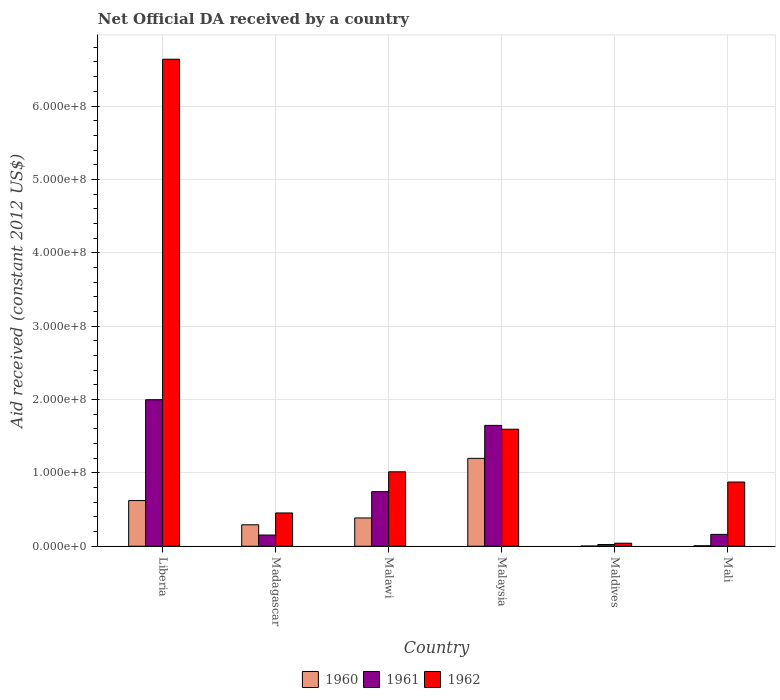Are the number of bars per tick equal to the number of legend labels?
Keep it short and to the point. Yes. How many bars are there on the 6th tick from the left?
Offer a very short reply. 3. What is the label of the 6th group of bars from the left?
Your answer should be very brief. Mali. In how many cases, is the number of bars for a given country not equal to the number of legend labels?
Ensure brevity in your answer.  0. What is the net official development assistance aid received in 1961 in Madagascar?
Your response must be concise. 1.53e+07. Across all countries, what is the maximum net official development assistance aid received in 1962?
Provide a short and direct response. 6.64e+08. Across all countries, what is the minimum net official development assistance aid received in 1961?
Make the answer very short. 2.33e+06. In which country was the net official development assistance aid received in 1961 maximum?
Provide a short and direct response. Liberia. In which country was the net official development assistance aid received in 1960 minimum?
Keep it short and to the point. Maldives. What is the total net official development assistance aid received in 1960 in the graph?
Offer a terse response. 2.51e+08. What is the difference between the net official development assistance aid received in 1960 in Madagascar and that in Maldives?
Make the answer very short. 2.90e+07. What is the difference between the net official development assistance aid received in 1961 in Madagascar and the net official development assistance aid received in 1962 in Malaysia?
Provide a succinct answer. -1.44e+08. What is the average net official development assistance aid received in 1960 per country?
Give a very brief answer. 4.18e+07. What is the difference between the net official development assistance aid received of/in 1961 and net official development assistance aid received of/in 1962 in Malawi?
Make the answer very short. -2.70e+07. What is the ratio of the net official development assistance aid received in 1960 in Liberia to that in Madagascar?
Keep it short and to the point. 2.13. Is the net official development assistance aid received in 1960 in Malawi less than that in Mali?
Keep it short and to the point. No. What is the difference between the highest and the second highest net official development assistance aid received in 1961?
Your answer should be very brief. 1.25e+08. What is the difference between the highest and the lowest net official development assistance aid received in 1960?
Provide a succinct answer. 1.20e+08. Is the sum of the net official development assistance aid received in 1961 in Madagascar and Malaysia greater than the maximum net official development assistance aid received in 1962 across all countries?
Ensure brevity in your answer.  No. What does the 3rd bar from the right in Madagascar represents?
Provide a succinct answer. 1960. How many bars are there?
Ensure brevity in your answer.  18. How many countries are there in the graph?
Offer a very short reply. 6. Does the graph contain grids?
Give a very brief answer. Yes. Where does the legend appear in the graph?
Your answer should be very brief. Bottom center. How are the legend labels stacked?
Offer a very short reply. Horizontal. What is the title of the graph?
Your response must be concise. Net Official DA received by a country. What is the label or title of the X-axis?
Your response must be concise. Country. What is the label or title of the Y-axis?
Your answer should be very brief. Aid received (constant 2012 US$). What is the Aid received (constant 2012 US$) of 1960 in Liberia?
Ensure brevity in your answer.  6.23e+07. What is the Aid received (constant 2012 US$) in 1961 in Liberia?
Your response must be concise. 2.00e+08. What is the Aid received (constant 2012 US$) in 1962 in Liberia?
Your answer should be very brief. 6.64e+08. What is the Aid received (constant 2012 US$) of 1960 in Madagascar?
Your answer should be compact. 2.92e+07. What is the Aid received (constant 2012 US$) in 1961 in Madagascar?
Ensure brevity in your answer.  1.53e+07. What is the Aid received (constant 2012 US$) in 1962 in Madagascar?
Provide a succinct answer. 4.54e+07. What is the Aid received (constant 2012 US$) in 1960 in Malawi?
Give a very brief answer. 3.86e+07. What is the Aid received (constant 2012 US$) in 1961 in Malawi?
Make the answer very short. 7.44e+07. What is the Aid received (constant 2012 US$) in 1962 in Malawi?
Your answer should be compact. 1.01e+08. What is the Aid received (constant 2012 US$) of 1960 in Malaysia?
Offer a terse response. 1.20e+08. What is the Aid received (constant 2012 US$) of 1961 in Malaysia?
Make the answer very short. 1.65e+08. What is the Aid received (constant 2012 US$) in 1962 in Malaysia?
Provide a succinct answer. 1.59e+08. What is the Aid received (constant 2012 US$) of 1961 in Maldives?
Your answer should be very brief. 2.33e+06. What is the Aid received (constant 2012 US$) of 1962 in Maldives?
Keep it short and to the point. 4.15e+06. What is the Aid received (constant 2012 US$) in 1960 in Mali?
Give a very brief answer. 6.60e+05. What is the Aid received (constant 2012 US$) of 1961 in Mali?
Keep it short and to the point. 1.62e+07. What is the Aid received (constant 2012 US$) in 1962 in Mali?
Ensure brevity in your answer.  8.75e+07. Across all countries, what is the maximum Aid received (constant 2012 US$) of 1960?
Give a very brief answer. 1.20e+08. Across all countries, what is the maximum Aid received (constant 2012 US$) of 1961?
Your answer should be compact. 2.00e+08. Across all countries, what is the maximum Aid received (constant 2012 US$) of 1962?
Provide a succinct answer. 6.64e+08. Across all countries, what is the minimum Aid received (constant 2012 US$) of 1960?
Offer a very short reply. 2.70e+05. Across all countries, what is the minimum Aid received (constant 2012 US$) in 1961?
Provide a short and direct response. 2.33e+06. Across all countries, what is the minimum Aid received (constant 2012 US$) in 1962?
Your answer should be very brief. 4.15e+06. What is the total Aid received (constant 2012 US$) of 1960 in the graph?
Provide a short and direct response. 2.51e+08. What is the total Aid received (constant 2012 US$) of 1961 in the graph?
Your answer should be very brief. 4.73e+08. What is the total Aid received (constant 2012 US$) in 1962 in the graph?
Ensure brevity in your answer.  1.06e+09. What is the difference between the Aid received (constant 2012 US$) in 1960 in Liberia and that in Madagascar?
Your response must be concise. 3.30e+07. What is the difference between the Aid received (constant 2012 US$) of 1961 in Liberia and that in Madagascar?
Provide a succinct answer. 1.84e+08. What is the difference between the Aid received (constant 2012 US$) in 1962 in Liberia and that in Madagascar?
Make the answer very short. 6.18e+08. What is the difference between the Aid received (constant 2012 US$) of 1960 in Liberia and that in Malawi?
Provide a succinct answer. 2.37e+07. What is the difference between the Aid received (constant 2012 US$) in 1961 in Liberia and that in Malawi?
Offer a very short reply. 1.25e+08. What is the difference between the Aid received (constant 2012 US$) of 1962 in Liberia and that in Malawi?
Make the answer very short. 5.62e+08. What is the difference between the Aid received (constant 2012 US$) of 1960 in Liberia and that in Malaysia?
Your response must be concise. -5.75e+07. What is the difference between the Aid received (constant 2012 US$) in 1961 in Liberia and that in Malaysia?
Make the answer very short. 3.50e+07. What is the difference between the Aid received (constant 2012 US$) in 1962 in Liberia and that in Malaysia?
Offer a very short reply. 5.04e+08. What is the difference between the Aid received (constant 2012 US$) in 1960 in Liberia and that in Maldives?
Provide a succinct answer. 6.20e+07. What is the difference between the Aid received (constant 2012 US$) in 1961 in Liberia and that in Maldives?
Provide a short and direct response. 1.97e+08. What is the difference between the Aid received (constant 2012 US$) of 1962 in Liberia and that in Maldives?
Your answer should be compact. 6.60e+08. What is the difference between the Aid received (constant 2012 US$) in 1960 in Liberia and that in Mali?
Keep it short and to the point. 6.16e+07. What is the difference between the Aid received (constant 2012 US$) in 1961 in Liberia and that in Mali?
Provide a succinct answer. 1.84e+08. What is the difference between the Aid received (constant 2012 US$) in 1962 in Liberia and that in Mali?
Give a very brief answer. 5.76e+08. What is the difference between the Aid received (constant 2012 US$) in 1960 in Madagascar and that in Malawi?
Your answer should be compact. -9.30e+06. What is the difference between the Aid received (constant 2012 US$) of 1961 in Madagascar and that in Malawi?
Your answer should be very brief. -5.92e+07. What is the difference between the Aid received (constant 2012 US$) in 1962 in Madagascar and that in Malawi?
Ensure brevity in your answer.  -5.61e+07. What is the difference between the Aid received (constant 2012 US$) of 1960 in Madagascar and that in Malaysia?
Your answer should be very brief. -9.06e+07. What is the difference between the Aid received (constant 2012 US$) in 1961 in Madagascar and that in Malaysia?
Make the answer very short. -1.49e+08. What is the difference between the Aid received (constant 2012 US$) in 1962 in Madagascar and that in Malaysia?
Ensure brevity in your answer.  -1.14e+08. What is the difference between the Aid received (constant 2012 US$) of 1960 in Madagascar and that in Maldives?
Ensure brevity in your answer.  2.90e+07. What is the difference between the Aid received (constant 2012 US$) in 1961 in Madagascar and that in Maldives?
Give a very brief answer. 1.29e+07. What is the difference between the Aid received (constant 2012 US$) of 1962 in Madagascar and that in Maldives?
Offer a very short reply. 4.12e+07. What is the difference between the Aid received (constant 2012 US$) of 1960 in Madagascar and that in Mali?
Keep it short and to the point. 2.86e+07. What is the difference between the Aid received (constant 2012 US$) in 1961 in Madagascar and that in Mali?
Ensure brevity in your answer.  -9.00e+05. What is the difference between the Aid received (constant 2012 US$) of 1962 in Madagascar and that in Mali?
Give a very brief answer. -4.22e+07. What is the difference between the Aid received (constant 2012 US$) in 1960 in Malawi and that in Malaysia?
Offer a terse response. -8.12e+07. What is the difference between the Aid received (constant 2012 US$) of 1961 in Malawi and that in Malaysia?
Your answer should be very brief. -9.03e+07. What is the difference between the Aid received (constant 2012 US$) of 1962 in Malawi and that in Malaysia?
Offer a very short reply. -5.80e+07. What is the difference between the Aid received (constant 2012 US$) of 1960 in Malawi and that in Maldives?
Your answer should be compact. 3.83e+07. What is the difference between the Aid received (constant 2012 US$) of 1961 in Malawi and that in Maldives?
Offer a terse response. 7.21e+07. What is the difference between the Aid received (constant 2012 US$) of 1962 in Malawi and that in Maldives?
Ensure brevity in your answer.  9.73e+07. What is the difference between the Aid received (constant 2012 US$) in 1960 in Malawi and that in Mali?
Provide a short and direct response. 3.79e+07. What is the difference between the Aid received (constant 2012 US$) in 1961 in Malawi and that in Mali?
Provide a short and direct response. 5.83e+07. What is the difference between the Aid received (constant 2012 US$) in 1962 in Malawi and that in Mali?
Provide a short and direct response. 1.39e+07. What is the difference between the Aid received (constant 2012 US$) in 1960 in Malaysia and that in Maldives?
Give a very brief answer. 1.20e+08. What is the difference between the Aid received (constant 2012 US$) of 1961 in Malaysia and that in Maldives?
Your answer should be very brief. 1.62e+08. What is the difference between the Aid received (constant 2012 US$) of 1962 in Malaysia and that in Maldives?
Make the answer very short. 1.55e+08. What is the difference between the Aid received (constant 2012 US$) in 1960 in Malaysia and that in Mali?
Your answer should be compact. 1.19e+08. What is the difference between the Aid received (constant 2012 US$) of 1961 in Malaysia and that in Mali?
Keep it short and to the point. 1.49e+08. What is the difference between the Aid received (constant 2012 US$) of 1962 in Malaysia and that in Mali?
Ensure brevity in your answer.  7.20e+07. What is the difference between the Aid received (constant 2012 US$) of 1960 in Maldives and that in Mali?
Give a very brief answer. -3.90e+05. What is the difference between the Aid received (constant 2012 US$) in 1961 in Maldives and that in Mali?
Give a very brief answer. -1.38e+07. What is the difference between the Aid received (constant 2012 US$) of 1962 in Maldives and that in Mali?
Provide a short and direct response. -8.34e+07. What is the difference between the Aid received (constant 2012 US$) of 1960 in Liberia and the Aid received (constant 2012 US$) of 1961 in Madagascar?
Your answer should be very brief. 4.70e+07. What is the difference between the Aid received (constant 2012 US$) of 1960 in Liberia and the Aid received (constant 2012 US$) of 1962 in Madagascar?
Provide a succinct answer. 1.69e+07. What is the difference between the Aid received (constant 2012 US$) of 1961 in Liberia and the Aid received (constant 2012 US$) of 1962 in Madagascar?
Offer a very short reply. 1.54e+08. What is the difference between the Aid received (constant 2012 US$) in 1960 in Liberia and the Aid received (constant 2012 US$) in 1961 in Malawi?
Offer a very short reply. -1.22e+07. What is the difference between the Aid received (constant 2012 US$) in 1960 in Liberia and the Aid received (constant 2012 US$) in 1962 in Malawi?
Ensure brevity in your answer.  -3.92e+07. What is the difference between the Aid received (constant 2012 US$) in 1961 in Liberia and the Aid received (constant 2012 US$) in 1962 in Malawi?
Keep it short and to the point. 9.82e+07. What is the difference between the Aid received (constant 2012 US$) in 1960 in Liberia and the Aid received (constant 2012 US$) in 1961 in Malaysia?
Offer a terse response. -1.02e+08. What is the difference between the Aid received (constant 2012 US$) of 1960 in Liberia and the Aid received (constant 2012 US$) of 1962 in Malaysia?
Give a very brief answer. -9.72e+07. What is the difference between the Aid received (constant 2012 US$) in 1961 in Liberia and the Aid received (constant 2012 US$) in 1962 in Malaysia?
Ensure brevity in your answer.  4.02e+07. What is the difference between the Aid received (constant 2012 US$) in 1960 in Liberia and the Aid received (constant 2012 US$) in 1961 in Maldives?
Your response must be concise. 6.00e+07. What is the difference between the Aid received (constant 2012 US$) in 1960 in Liberia and the Aid received (constant 2012 US$) in 1962 in Maldives?
Provide a short and direct response. 5.81e+07. What is the difference between the Aid received (constant 2012 US$) in 1961 in Liberia and the Aid received (constant 2012 US$) in 1962 in Maldives?
Give a very brief answer. 1.96e+08. What is the difference between the Aid received (constant 2012 US$) of 1960 in Liberia and the Aid received (constant 2012 US$) of 1961 in Mali?
Offer a very short reply. 4.61e+07. What is the difference between the Aid received (constant 2012 US$) in 1960 in Liberia and the Aid received (constant 2012 US$) in 1962 in Mali?
Your response must be concise. -2.52e+07. What is the difference between the Aid received (constant 2012 US$) of 1961 in Liberia and the Aid received (constant 2012 US$) of 1962 in Mali?
Your answer should be compact. 1.12e+08. What is the difference between the Aid received (constant 2012 US$) of 1960 in Madagascar and the Aid received (constant 2012 US$) of 1961 in Malawi?
Keep it short and to the point. -4.52e+07. What is the difference between the Aid received (constant 2012 US$) of 1960 in Madagascar and the Aid received (constant 2012 US$) of 1962 in Malawi?
Offer a very short reply. -7.22e+07. What is the difference between the Aid received (constant 2012 US$) of 1961 in Madagascar and the Aid received (constant 2012 US$) of 1962 in Malawi?
Provide a succinct answer. -8.62e+07. What is the difference between the Aid received (constant 2012 US$) of 1960 in Madagascar and the Aid received (constant 2012 US$) of 1961 in Malaysia?
Offer a terse response. -1.35e+08. What is the difference between the Aid received (constant 2012 US$) in 1960 in Madagascar and the Aid received (constant 2012 US$) in 1962 in Malaysia?
Your answer should be compact. -1.30e+08. What is the difference between the Aid received (constant 2012 US$) in 1961 in Madagascar and the Aid received (constant 2012 US$) in 1962 in Malaysia?
Your answer should be very brief. -1.44e+08. What is the difference between the Aid received (constant 2012 US$) in 1960 in Madagascar and the Aid received (constant 2012 US$) in 1961 in Maldives?
Ensure brevity in your answer.  2.69e+07. What is the difference between the Aid received (constant 2012 US$) in 1960 in Madagascar and the Aid received (constant 2012 US$) in 1962 in Maldives?
Provide a short and direct response. 2.51e+07. What is the difference between the Aid received (constant 2012 US$) of 1961 in Madagascar and the Aid received (constant 2012 US$) of 1962 in Maldives?
Ensure brevity in your answer.  1.11e+07. What is the difference between the Aid received (constant 2012 US$) of 1960 in Madagascar and the Aid received (constant 2012 US$) of 1961 in Mali?
Your answer should be compact. 1.31e+07. What is the difference between the Aid received (constant 2012 US$) in 1960 in Madagascar and the Aid received (constant 2012 US$) in 1962 in Mali?
Offer a terse response. -5.83e+07. What is the difference between the Aid received (constant 2012 US$) in 1961 in Madagascar and the Aid received (constant 2012 US$) in 1962 in Mali?
Offer a very short reply. -7.23e+07. What is the difference between the Aid received (constant 2012 US$) in 1960 in Malawi and the Aid received (constant 2012 US$) in 1961 in Malaysia?
Keep it short and to the point. -1.26e+08. What is the difference between the Aid received (constant 2012 US$) in 1960 in Malawi and the Aid received (constant 2012 US$) in 1962 in Malaysia?
Your response must be concise. -1.21e+08. What is the difference between the Aid received (constant 2012 US$) in 1961 in Malawi and the Aid received (constant 2012 US$) in 1962 in Malaysia?
Your answer should be very brief. -8.50e+07. What is the difference between the Aid received (constant 2012 US$) of 1960 in Malawi and the Aid received (constant 2012 US$) of 1961 in Maldives?
Make the answer very short. 3.62e+07. What is the difference between the Aid received (constant 2012 US$) in 1960 in Malawi and the Aid received (constant 2012 US$) in 1962 in Maldives?
Ensure brevity in your answer.  3.44e+07. What is the difference between the Aid received (constant 2012 US$) of 1961 in Malawi and the Aid received (constant 2012 US$) of 1962 in Maldives?
Provide a short and direct response. 7.03e+07. What is the difference between the Aid received (constant 2012 US$) in 1960 in Malawi and the Aid received (constant 2012 US$) in 1961 in Mali?
Provide a short and direct response. 2.24e+07. What is the difference between the Aid received (constant 2012 US$) in 1960 in Malawi and the Aid received (constant 2012 US$) in 1962 in Mali?
Your answer should be compact. -4.90e+07. What is the difference between the Aid received (constant 2012 US$) of 1961 in Malawi and the Aid received (constant 2012 US$) of 1962 in Mali?
Keep it short and to the point. -1.31e+07. What is the difference between the Aid received (constant 2012 US$) of 1960 in Malaysia and the Aid received (constant 2012 US$) of 1961 in Maldives?
Your response must be concise. 1.17e+08. What is the difference between the Aid received (constant 2012 US$) of 1960 in Malaysia and the Aid received (constant 2012 US$) of 1962 in Maldives?
Your response must be concise. 1.16e+08. What is the difference between the Aid received (constant 2012 US$) of 1961 in Malaysia and the Aid received (constant 2012 US$) of 1962 in Maldives?
Offer a terse response. 1.61e+08. What is the difference between the Aid received (constant 2012 US$) of 1960 in Malaysia and the Aid received (constant 2012 US$) of 1961 in Mali?
Keep it short and to the point. 1.04e+08. What is the difference between the Aid received (constant 2012 US$) of 1960 in Malaysia and the Aid received (constant 2012 US$) of 1962 in Mali?
Provide a short and direct response. 3.23e+07. What is the difference between the Aid received (constant 2012 US$) in 1961 in Malaysia and the Aid received (constant 2012 US$) in 1962 in Mali?
Ensure brevity in your answer.  7.72e+07. What is the difference between the Aid received (constant 2012 US$) in 1960 in Maldives and the Aid received (constant 2012 US$) in 1961 in Mali?
Offer a terse response. -1.59e+07. What is the difference between the Aid received (constant 2012 US$) of 1960 in Maldives and the Aid received (constant 2012 US$) of 1962 in Mali?
Keep it short and to the point. -8.73e+07. What is the difference between the Aid received (constant 2012 US$) of 1961 in Maldives and the Aid received (constant 2012 US$) of 1962 in Mali?
Your response must be concise. -8.52e+07. What is the average Aid received (constant 2012 US$) in 1960 per country?
Provide a succinct answer. 4.18e+07. What is the average Aid received (constant 2012 US$) in 1961 per country?
Provide a succinct answer. 7.88e+07. What is the average Aid received (constant 2012 US$) of 1962 per country?
Give a very brief answer. 1.77e+08. What is the difference between the Aid received (constant 2012 US$) of 1960 and Aid received (constant 2012 US$) of 1961 in Liberia?
Your answer should be very brief. -1.37e+08. What is the difference between the Aid received (constant 2012 US$) of 1960 and Aid received (constant 2012 US$) of 1962 in Liberia?
Your response must be concise. -6.01e+08. What is the difference between the Aid received (constant 2012 US$) in 1961 and Aid received (constant 2012 US$) in 1962 in Liberia?
Offer a terse response. -4.64e+08. What is the difference between the Aid received (constant 2012 US$) of 1960 and Aid received (constant 2012 US$) of 1961 in Madagascar?
Ensure brevity in your answer.  1.40e+07. What is the difference between the Aid received (constant 2012 US$) in 1960 and Aid received (constant 2012 US$) in 1962 in Madagascar?
Your answer should be very brief. -1.61e+07. What is the difference between the Aid received (constant 2012 US$) of 1961 and Aid received (constant 2012 US$) of 1962 in Madagascar?
Ensure brevity in your answer.  -3.01e+07. What is the difference between the Aid received (constant 2012 US$) in 1960 and Aid received (constant 2012 US$) in 1961 in Malawi?
Your answer should be compact. -3.59e+07. What is the difference between the Aid received (constant 2012 US$) in 1960 and Aid received (constant 2012 US$) in 1962 in Malawi?
Keep it short and to the point. -6.29e+07. What is the difference between the Aid received (constant 2012 US$) of 1961 and Aid received (constant 2012 US$) of 1962 in Malawi?
Provide a succinct answer. -2.70e+07. What is the difference between the Aid received (constant 2012 US$) in 1960 and Aid received (constant 2012 US$) in 1961 in Malaysia?
Give a very brief answer. -4.49e+07. What is the difference between the Aid received (constant 2012 US$) of 1960 and Aid received (constant 2012 US$) of 1962 in Malaysia?
Your answer should be very brief. -3.97e+07. What is the difference between the Aid received (constant 2012 US$) in 1961 and Aid received (constant 2012 US$) in 1962 in Malaysia?
Your answer should be compact. 5.24e+06. What is the difference between the Aid received (constant 2012 US$) of 1960 and Aid received (constant 2012 US$) of 1961 in Maldives?
Provide a succinct answer. -2.06e+06. What is the difference between the Aid received (constant 2012 US$) in 1960 and Aid received (constant 2012 US$) in 1962 in Maldives?
Offer a very short reply. -3.88e+06. What is the difference between the Aid received (constant 2012 US$) of 1961 and Aid received (constant 2012 US$) of 1962 in Maldives?
Provide a short and direct response. -1.82e+06. What is the difference between the Aid received (constant 2012 US$) in 1960 and Aid received (constant 2012 US$) in 1961 in Mali?
Give a very brief answer. -1.55e+07. What is the difference between the Aid received (constant 2012 US$) in 1960 and Aid received (constant 2012 US$) in 1962 in Mali?
Keep it short and to the point. -8.69e+07. What is the difference between the Aid received (constant 2012 US$) of 1961 and Aid received (constant 2012 US$) of 1962 in Mali?
Your response must be concise. -7.14e+07. What is the ratio of the Aid received (constant 2012 US$) in 1960 in Liberia to that in Madagascar?
Ensure brevity in your answer.  2.13. What is the ratio of the Aid received (constant 2012 US$) of 1961 in Liberia to that in Madagascar?
Offer a very short reply. 13.08. What is the ratio of the Aid received (constant 2012 US$) of 1962 in Liberia to that in Madagascar?
Your answer should be compact. 14.63. What is the ratio of the Aid received (constant 2012 US$) in 1960 in Liberia to that in Malawi?
Offer a terse response. 1.62. What is the ratio of the Aid received (constant 2012 US$) of 1961 in Liberia to that in Malawi?
Make the answer very short. 2.68. What is the ratio of the Aid received (constant 2012 US$) in 1962 in Liberia to that in Malawi?
Keep it short and to the point. 6.54. What is the ratio of the Aid received (constant 2012 US$) of 1960 in Liberia to that in Malaysia?
Your answer should be compact. 0.52. What is the ratio of the Aid received (constant 2012 US$) of 1961 in Liberia to that in Malaysia?
Your response must be concise. 1.21. What is the ratio of the Aid received (constant 2012 US$) in 1962 in Liberia to that in Malaysia?
Your response must be concise. 4.16. What is the ratio of the Aid received (constant 2012 US$) in 1960 in Liberia to that in Maldives?
Your response must be concise. 230.67. What is the ratio of the Aid received (constant 2012 US$) in 1961 in Liberia to that in Maldives?
Ensure brevity in your answer.  85.71. What is the ratio of the Aid received (constant 2012 US$) of 1962 in Liberia to that in Maldives?
Provide a succinct answer. 159.94. What is the ratio of the Aid received (constant 2012 US$) of 1960 in Liberia to that in Mali?
Ensure brevity in your answer.  94.36. What is the ratio of the Aid received (constant 2012 US$) of 1961 in Liberia to that in Mali?
Your response must be concise. 12.35. What is the ratio of the Aid received (constant 2012 US$) in 1962 in Liberia to that in Mali?
Offer a terse response. 7.58. What is the ratio of the Aid received (constant 2012 US$) in 1960 in Madagascar to that in Malawi?
Keep it short and to the point. 0.76. What is the ratio of the Aid received (constant 2012 US$) in 1961 in Madagascar to that in Malawi?
Provide a succinct answer. 0.21. What is the ratio of the Aid received (constant 2012 US$) in 1962 in Madagascar to that in Malawi?
Offer a terse response. 0.45. What is the ratio of the Aid received (constant 2012 US$) of 1960 in Madagascar to that in Malaysia?
Keep it short and to the point. 0.24. What is the ratio of the Aid received (constant 2012 US$) in 1961 in Madagascar to that in Malaysia?
Your answer should be compact. 0.09. What is the ratio of the Aid received (constant 2012 US$) in 1962 in Madagascar to that in Malaysia?
Your answer should be compact. 0.28. What is the ratio of the Aid received (constant 2012 US$) in 1960 in Madagascar to that in Maldives?
Offer a terse response. 108.33. What is the ratio of the Aid received (constant 2012 US$) in 1961 in Madagascar to that in Maldives?
Make the answer very short. 6.55. What is the ratio of the Aid received (constant 2012 US$) in 1962 in Madagascar to that in Maldives?
Provide a short and direct response. 10.93. What is the ratio of the Aid received (constant 2012 US$) in 1960 in Madagascar to that in Mali?
Offer a very short reply. 44.32. What is the ratio of the Aid received (constant 2012 US$) in 1961 in Madagascar to that in Mali?
Your response must be concise. 0.94. What is the ratio of the Aid received (constant 2012 US$) of 1962 in Madagascar to that in Mali?
Offer a terse response. 0.52. What is the ratio of the Aid received (constant 2012 US$) in 1960 in Malawi to that in Malaysia?
Ensure brevity in your answer.  0.32. What is the ratio of the Aid received (constant 2012 US$) of 1961 in Malawi to that in Malaysia?
Your answer should be very brief. 0.45. What is the ratio of the Aid received (constant 2012 US$) in 1962 in Malawi to that in Malaysia?
Give a very brief answer. 0.64. What is the ratio of the Aid received (constant 2012 US$) in 1960 in Malawi to that in Maldives?
Your response must be concise. 142.78. What is the ratio of the Aid received (constant 2012 US$) of 1961 in Malawi to that in Maldives?
Your answer should be compact. 31.94. What is the ratio of the Aid received (constant 2012 US$) in 1962 in Malawi to that in Maldives?
Your answer should be compact. 24.45. What is the ratio of the Aid received (constant 2012 US$) of 1960 in Malawi to that in Mali?
Provide a succinct answer. 58.41. What is the ratio of the Aid received (constant 2012 US$) of 1961 in Malawi to that in Mali?
Offer a terse response. 4.6. What is the ratio of the Aid received (constant 2012 US$) of 1962 in Malawi to that in Mali?
Make the answer very short. 1.16. What is the ratio of the Aid received (constant 2012 US$) of 1960 in Malaysia to that in Maldives?
Provide a succinct answer. 443.7. What is the ratio of the Aid received (constant 2012 US$) of 1961 in Malaysia to that in Maldives?
Offer a very short reply. 70.7. What is the ratio of the Aid received (constant 2012 US$) in 1962 in Malaysia to that in Maldives?
Your answer should be very brief. 38.43. What is the ratio of the Aid received (constant 2012 US$) of 1960 in Malaysia to that in Mali?
Your answer should be compact. 181.52. What is the ratio of the Aid received (constant 2012 US$) in 1961 in Malaysia to that in Mali?
Offer a terse response. 10.19. What is the ratio of the Aid received (constant 2012 US$) of 1962 in Malaysia to that in Mali?
Make the answer very short. 1.82. What is the ratio of the Aid received (constant 2012 US$) in 1960 in Maldives to that in Mali?
Ensure brevity in your answer.  0.41. What is the ratio of the Aid received (constant 2012 US$) in 1961 in Maldives to that in Mali?
Offer a terse response. 0.14. What is the ratio of the Aid received (constant 2012 US$) of 1962 in Maldives to that in Mali?
Offer a terse response. 0.05. What is the difference between the highest and the second highest Aid received (constant 2012 US$) of 1960?
Offer a very short reply. 5.75e+07. What is the difference between the highest and the second highest Aid received (constant 2012 US$) in 1961?
Give a very brief answer. 3.50e+07. What is the difference between the highest and the second highest Aid received (constant 2012 US$) of 1962?
Your response must be concise. 5.04e+08. What is the difference between the highest and the lowest Aid received (constant 2012 US$) in 1960?
Offer a very short reply. 1.20e+08. What is the difference between the highest and the lowest Aid received (constant 2012 US$) in 1961?
Provide a succinct answer. 1.97e+08. What is the difference between the highest and the lowest Aid received (constant 2012 US$) of 1962?
Your response must be concise. 6.60e+08. 